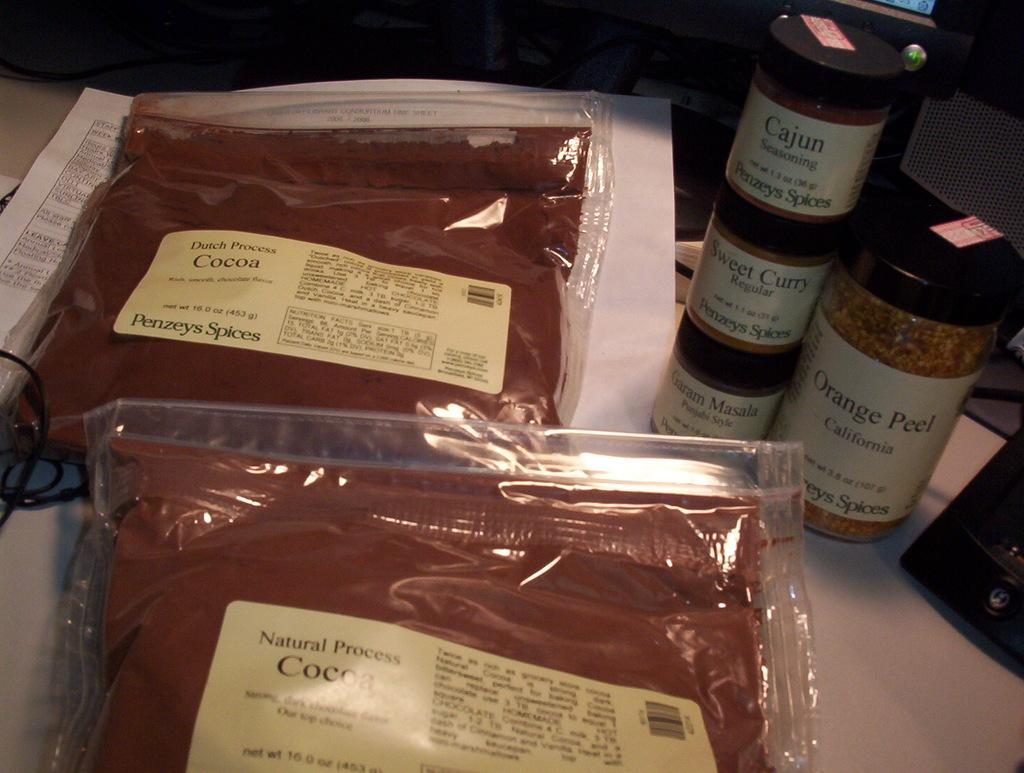<image>
Give a short and clear explanation of the subsequent image. Two packages of Dutch process Cocoa next to jars of spices including curry and Cajun seasoning. 